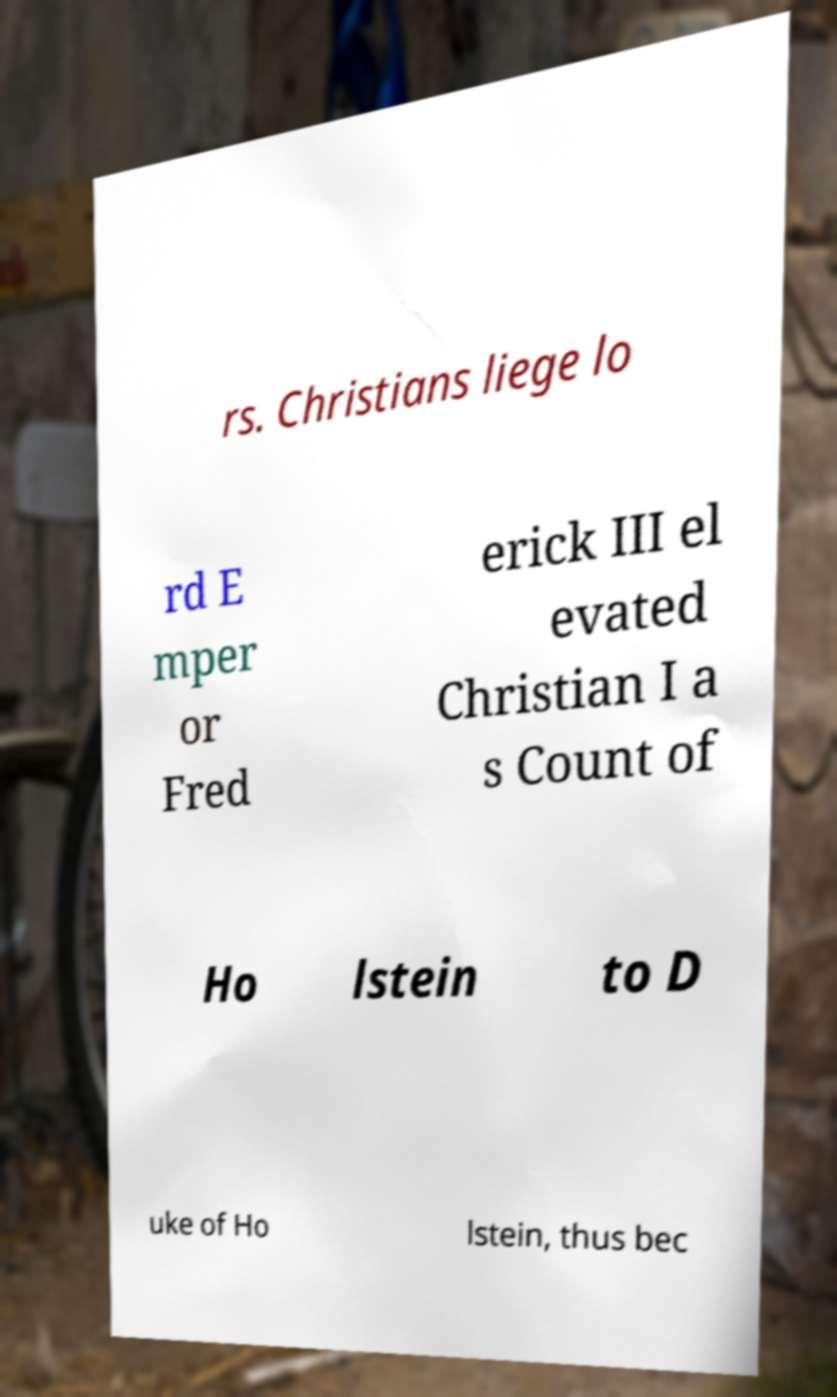I need the written content from this picture converted into text. Can you do that? rs. Christians liege lo rd E mper or Fred erick III el evated Christian I a s Count of Ho lstein to D uke of Ho lstein, thus bec 